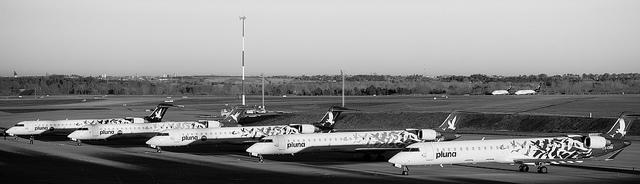Are all planes facing the same way?
Short answer required. Yes. What type of plane are these?
Write a very short answer. Commercial. How many planes are there?
Write a very short answer. 5. 